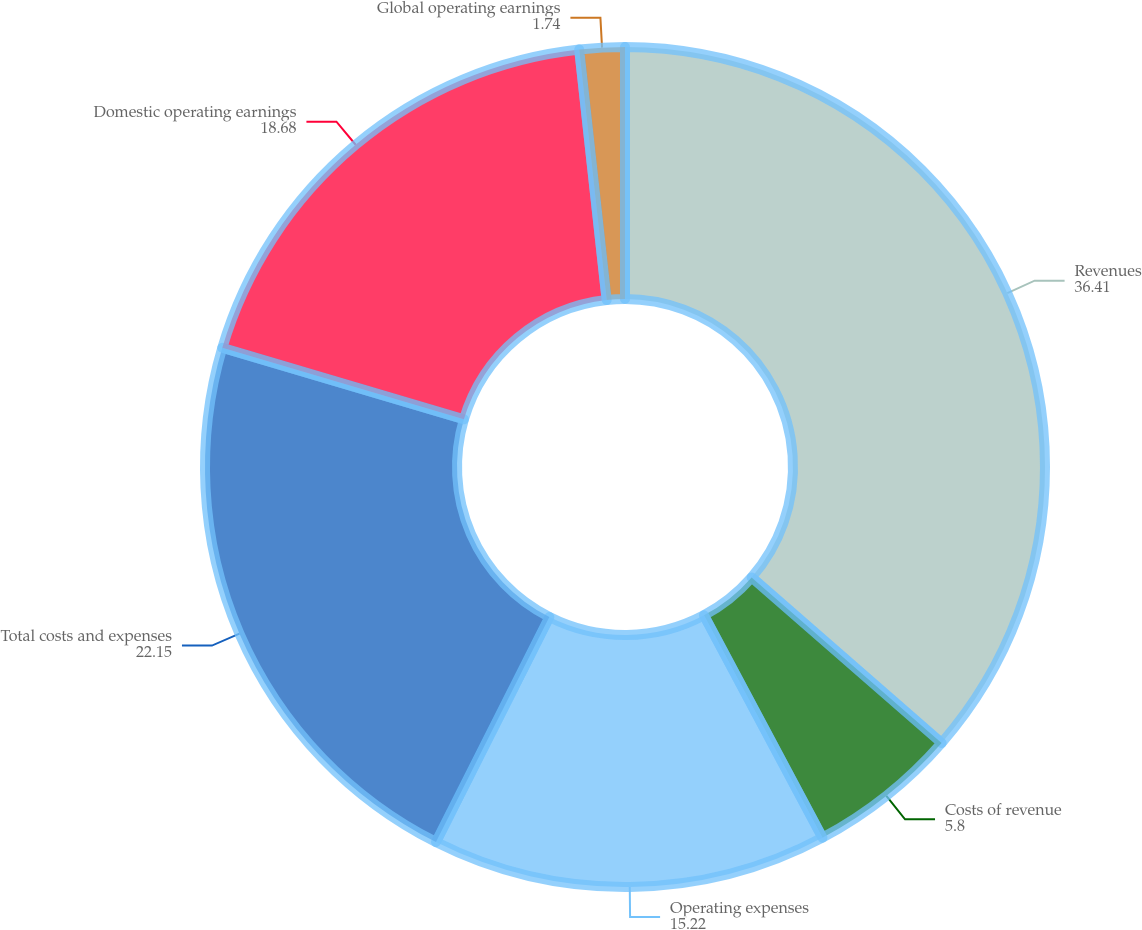Convert chart to OTSL. <chart><loc_0><loc_0><loc_500><loc_500><pie_chart><fcel>Revenues<fcel>Costs of revenue<fcel>Operating expenses<fcel>Total costs and expenses<fcel>Domestic operating earnings<fcel>Global operating earnings<nl><fcel>36.41%<fcel>5.8%<fcel>15.22%<fcel>22.15%<fcel>18.68%<fcel>1.74%<nl></chart> 